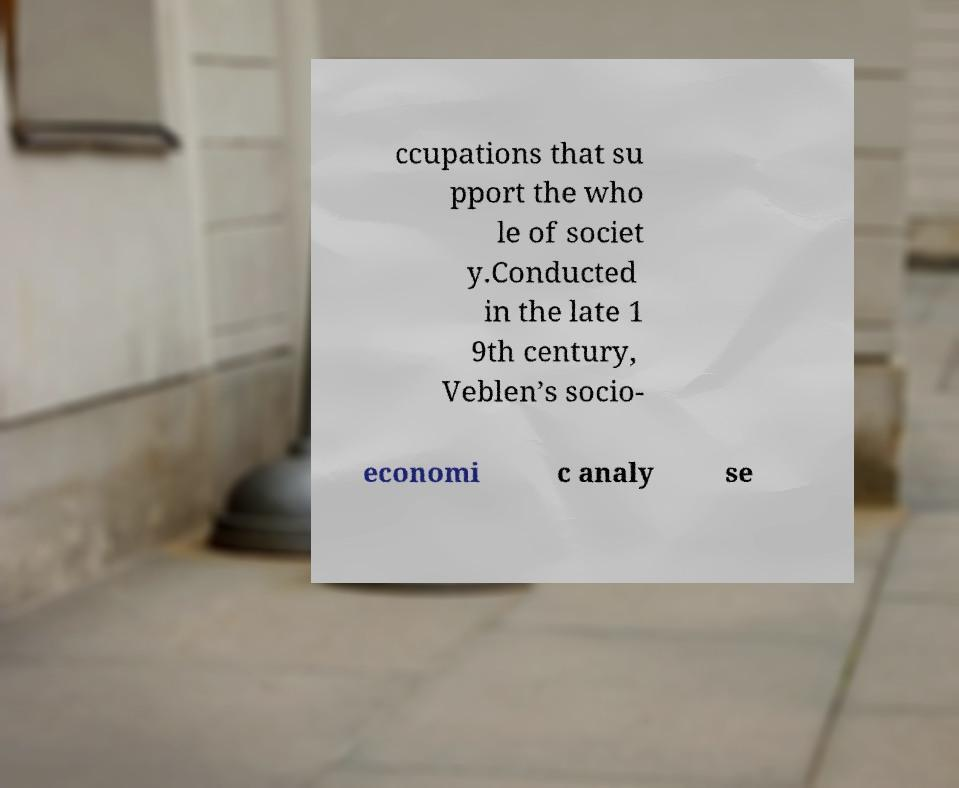Please read and relay the text visible in this image. What does it say? ccupations that su pport the who le of societ y.Conducted in the late 1 9th century, Veblen’s socio- economi c analy se 